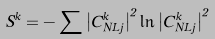<formula> <loc_0><loc_0><loc_500><loc_500>S ^ { k } = - \sum { \left | { C _ { N L j } ^ { k } } \right | ^ { 2 } \ln \left | { C _ { N L j } ^ { k } } \right | ^ { 2 } }</formula> 